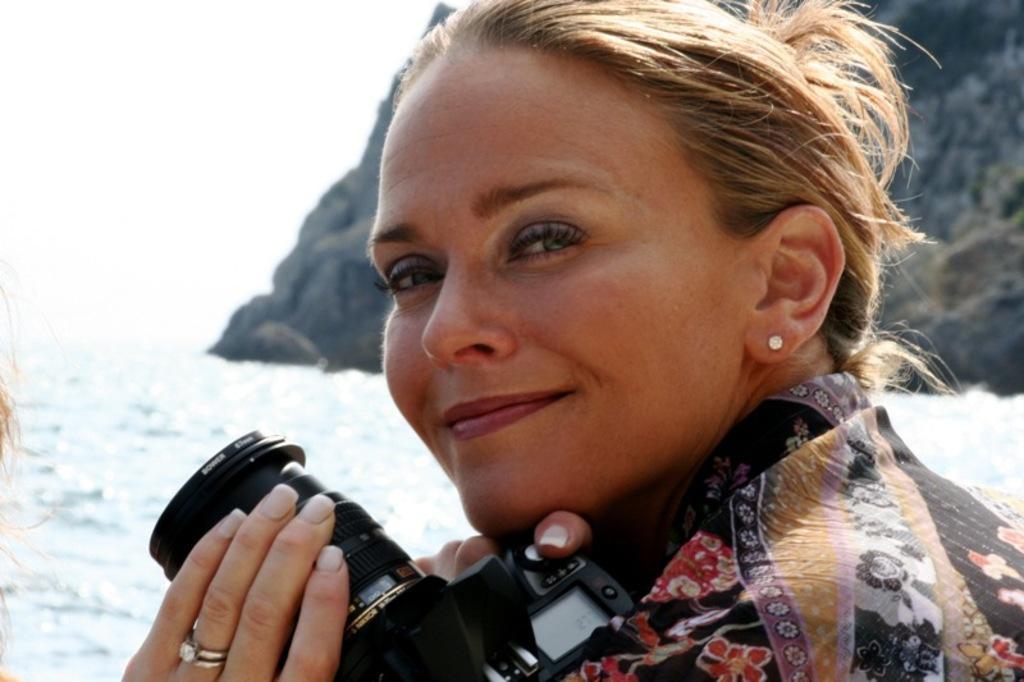How would you summarize this image in a sentence or two? In this picture there is a woman standing, smiling and she is holding a camera in her hands in the back of the mountain and snow 